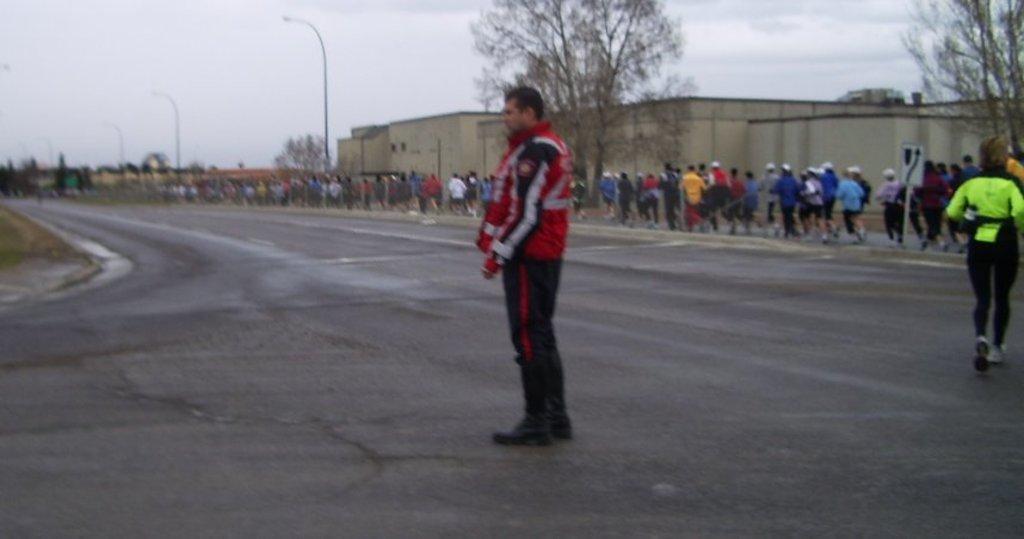Please provide a concise description of this image. In this picture we can see a man standing in the middle of the road surrounded by trees and houses. On the right side corner we can see many people running on the side path of the road. 